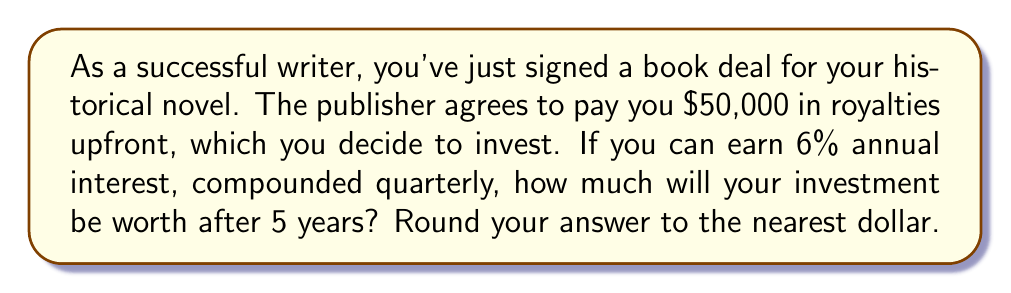Provide a solution to this math problem. To solve this problem, we'll use the compound interest formula:

$$A = P(1 + \frac{r}{n})^{nt}$$

Where:
$A$ = final amount
$P$ = principal (initial investment)
$r$ = annual interest rate (as a decimal)
$n$ = number of times interest is compounded per year
$t$ = number of years

Given:
$P = \$50,000$
$r = 0.06$ (6% expressed as a decimal)
$n = 4$ (compounded quarterly, so 4 times per year)
$t = 5$ years

Let's substitute these values into the formula:

$$A = 50000(1 + \frac{0.06}{4})^{4 \cdot 5}$$

$$A = 50000(1 + 0.015)^{20}$$

$$A = 50000(1.015)^{20}$$

Now, let's calculate $(1.015)^{20}$:

$$(1.015)^{20} \approx 1.3468789$$

Multiply this by the principal:

$$50000 \cdot 1.3468789 \approx 67343.95$$

Rounding to the nearest dollar gives us $67,344.
Answer: $67,344 